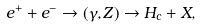Convert formula to latex. <formula><loc_0><loc_0><loc_500><loc_500>e ^ { + } + e ^ { - } \to ( \gamma , Z ) \to H _ { c } + X ,</formula> 